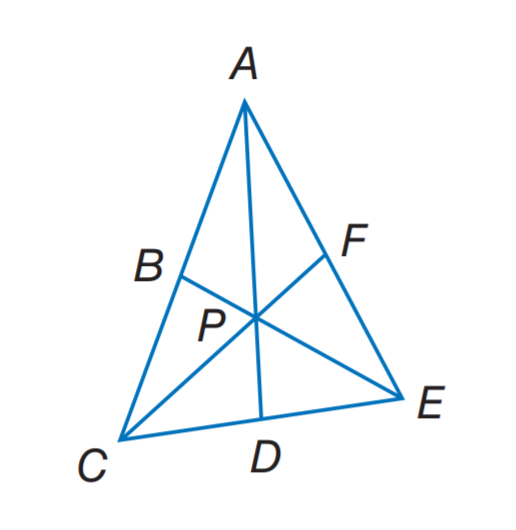Answer the mathemtical geometry problem and directly provide the correct option letter.
Question: In \triangle A C E, P is the centroid. P F = 6 and A D = 15. Find P C.
Choices: A: 6 B: 10 C: 12 D: 15 C 